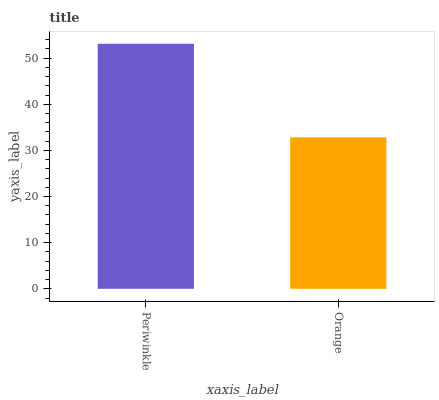Is Orange the maximum?
Answer yes or no. No. Is Periwinkle greater than Orange?
Answer yes or no. Yes. Is Orange less than Periwinkle?
Answer yes or no. Yes. Is Orange greater than Periwinkle?
Answer yes or no. No. Is Periwinkle less than Orange?
Answer yes or no. No. Is Periwinkle the high median?
Answer yes or no. Yes. Is Orange the low median?
Answer yes or no. Yes. Is Orange the high median?
Answer yes or no. No. Is Periwinkle the low median?
Answer yes or no. No. 